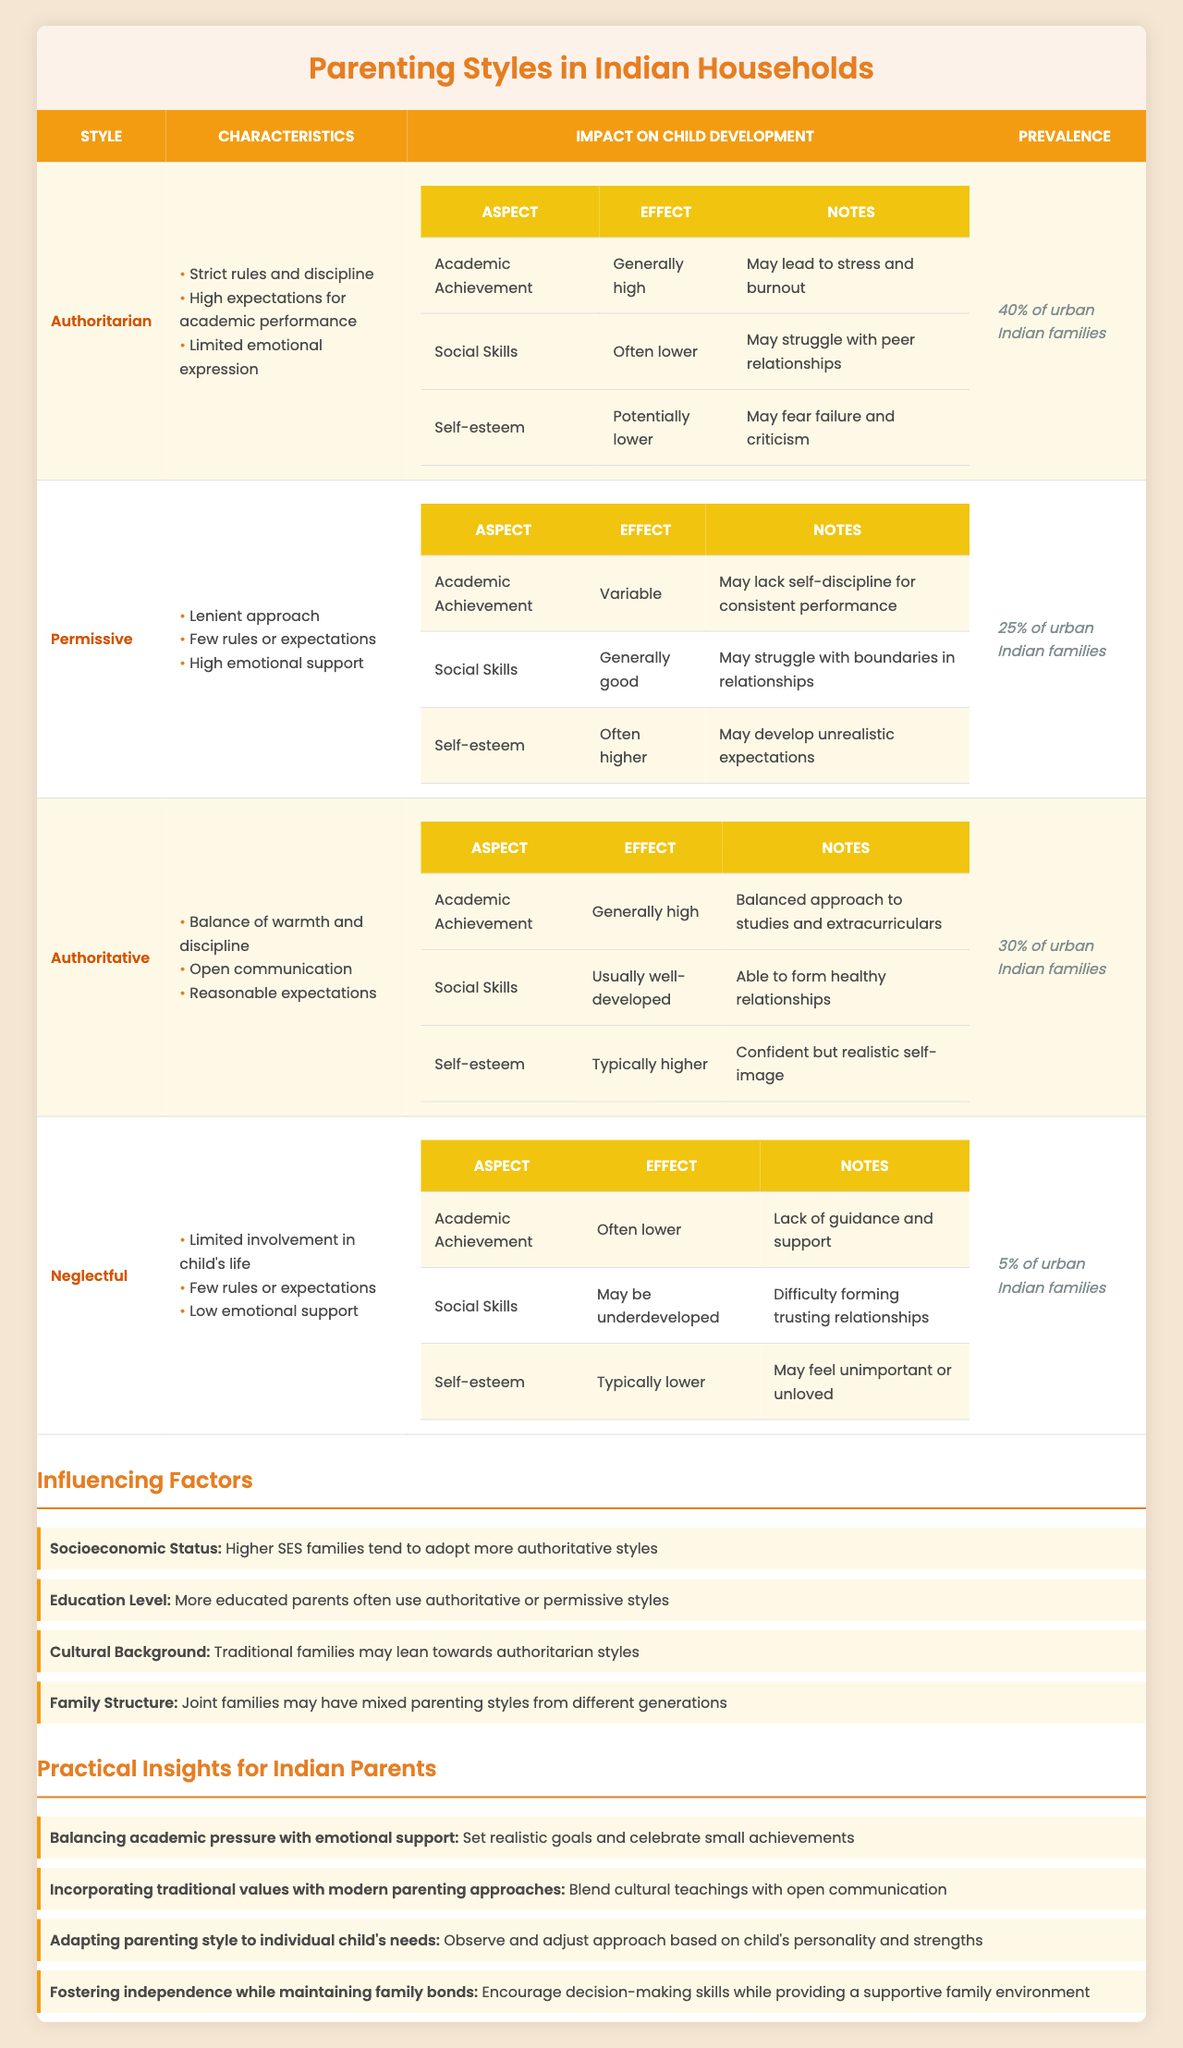What percentage of urban Indian families practice authoritarian parenting? The table states that authoritarian parenting is practiced by 40% of urban Indian families.
Answer: 40% What impact does the neglectful parenting style have on social skills? According to the table, neglectful parenting leads to underdeveloped social skills and difficulty forming trusting relationships.
Answer: May be underdeveloped Which parenting style is most likely to result in higher self-esteem for children? The table indicates that permissive parenting usually results in higher self-esteem, but it may also lead to unrealistic expectations.
Answer: Permissive What are the characteristics of authoritative parenting? The characteristics listed for authoritative parenting include a balance of warmth and discipline, open communication, and reasonable expectations.
Answer: Balance of warmth and discipline, open communication, reasonable expectations Calculate the average prevalence of the different parenting styles listed in the table. To find the average prevalence, convert the percentages to decimal form: 40% + 25% + 30% + 5% = 100%. Divide by 4 (number of styles), averaging to 100%/4 = 25%.
Answer: 25% Is the statement "Neglectful parenting has a high prevalence among urban Indian families" true or false? The table shows that neglectful parenting is only practiced by 5% of urban Indian families, which is low, making the statement false.
Answer: False How does socioeconomic status influence parenting styles according to the table? The table states that higher socioeconomic status families tend to adopt more authoritative styles, suggesting a correlation between these variables.
Answer: Higher SES leads to more authoritative styles Compare the impacts on academic achievement between authoritarian and neglectful parenting styles. The table states that authoritarian parenting results in generally high academic achievement, while neglectful parenting often leads to lower academic achievement. This shows a clear contrast in their impacts.
Answer: Authoritarian is generally high; neglectful is often lower What practical insight is given for balancing academic pressure in parenting? The table suggests setting realistic goals and celebrating small achievements as an insight to help balance academic pressure with emotional support.
Answer: Set realistic goals and celebrate small achievements Which parenting style usually leads to lower social skills? Based on the table, authoritarian parenting style usually leads to lower social skills in children.
Answer: Authoritarian 